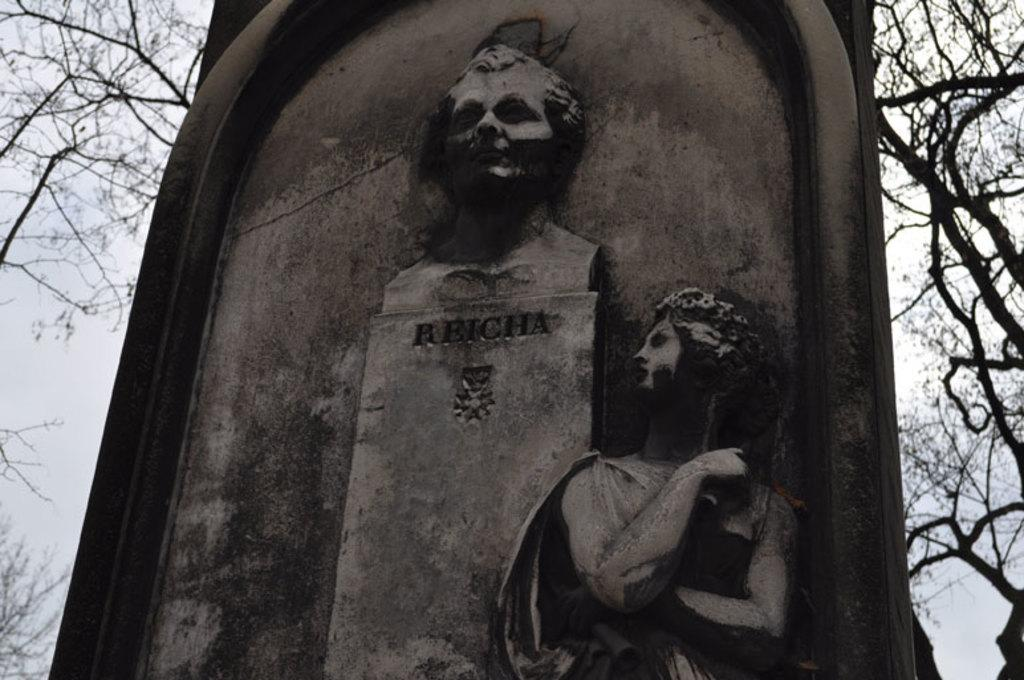What is depicted on the stone in the image? There is carving on a stone in the image, which resembles a gravestone. What can be seen in the background of the image? There are trees and the sky visible in the background of the image. What type of boat is visible in the image? There is no boat present in the image. How many screws can be seen holding the stone together in the image? The image does not show any screws, as it features a stone with carving that resembles a gravestone. 